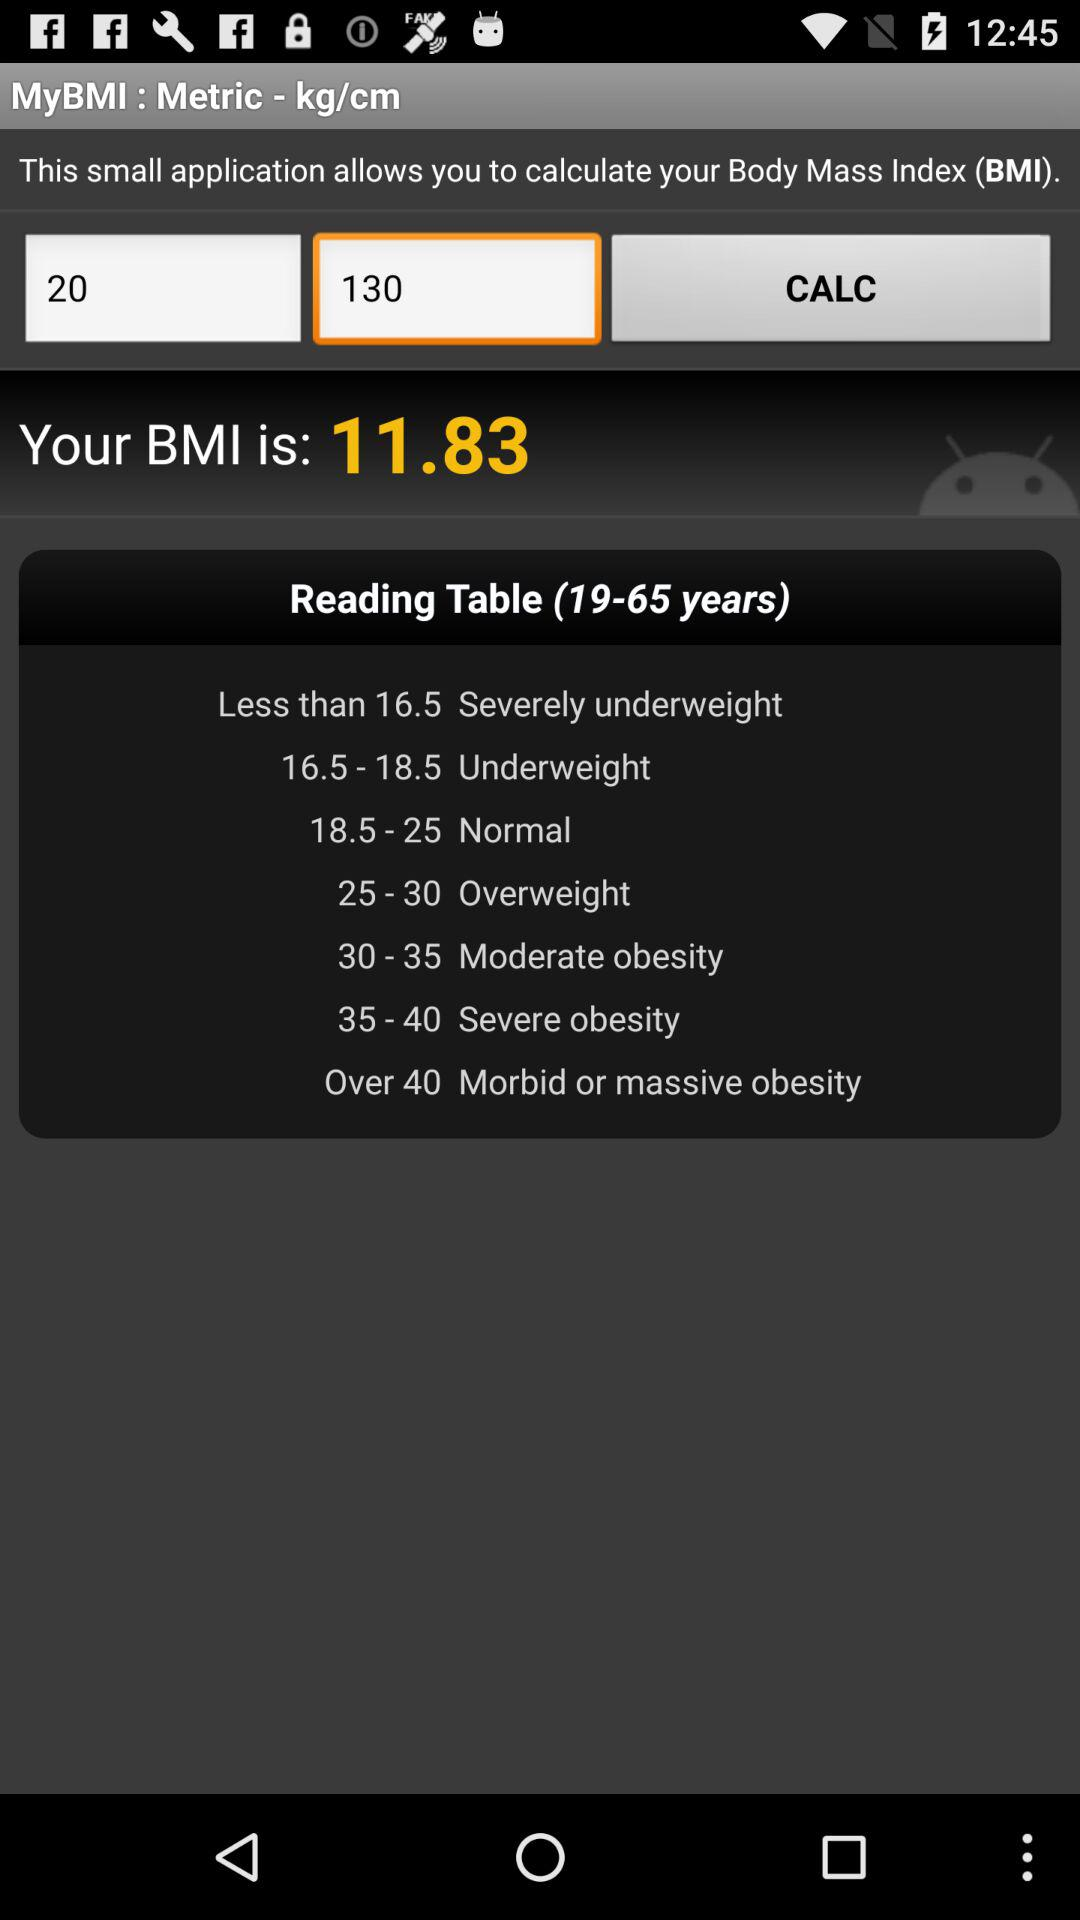What is the range of underweight? The range of underweight is between 16.5 and 18.5. 